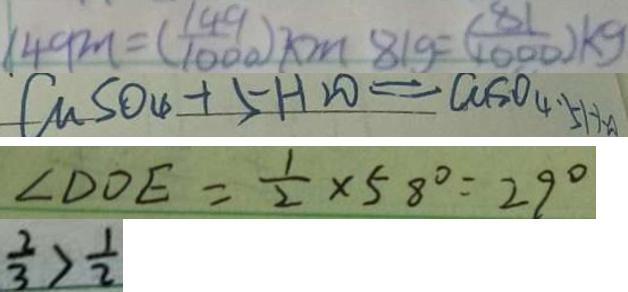<formula> <loc_0><loc_0><loc_500><loc_500>1 4 9 m = ( \frac { 1 4 9 } { 1 0 0 0 } ) k m 8 1 g = ( \frac { 8 1 } { 1 0 0 0 } ) k g 
 C u S O _ { 4 } + 5 H _ { 2 } O = C u S o _ { 4 } . 5 H _ { 2 } A 
 \angle D O E = \frac { 1 } { 2 } \times 5 8 ^ { \circ } = 2 9 ^ { \circ } 
 \frac { 2 } { 3 } > \frac { 1 } { 2 }</formula> 